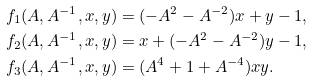Convert formula to latex. <formula><loc_0><loc_0><loc_500><loc_500>& f _ { 1 } ( A , A ^ { - 1 } , x , y ) = ( - A ^ { 2 } - A ^ { - 2 } ) x + y - 1 , \\ & f _ { 2 } ( A , A ^ { - 1 } , x , y ) = x + ( - A ^ { 2 } - A ^ { - 2 } ) y - 1 , \\ & f _ { 3 } ( A , A ^ { - 1 } , x , y ) = ( A ^ { 4 } + 1 + A ^ { - 4 } ) x y .</formula> 